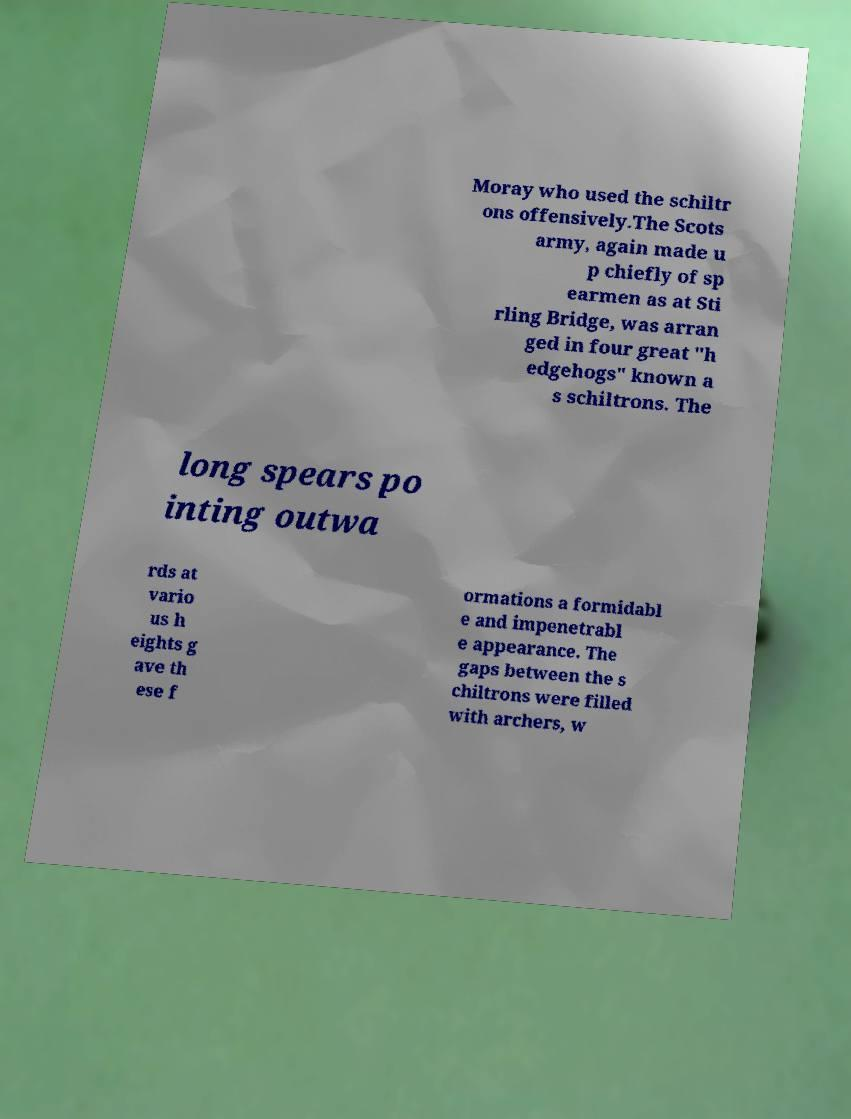What messages or text are displayed in this image? I need them in a readable, typed format. Moray who used the schiltr ons offensively.The Scots army, again made u p chiefly of sp earmen as at Sti rling Bridge, was arran ged in four great "h edgehogs" known a s schiltrons. The long spears po inting outwa rds at vario us h eights g ave th ese f ormations a formidabl e and impenetrabl e appearance. The gaps between the s chiltrons were filled with archers, w 